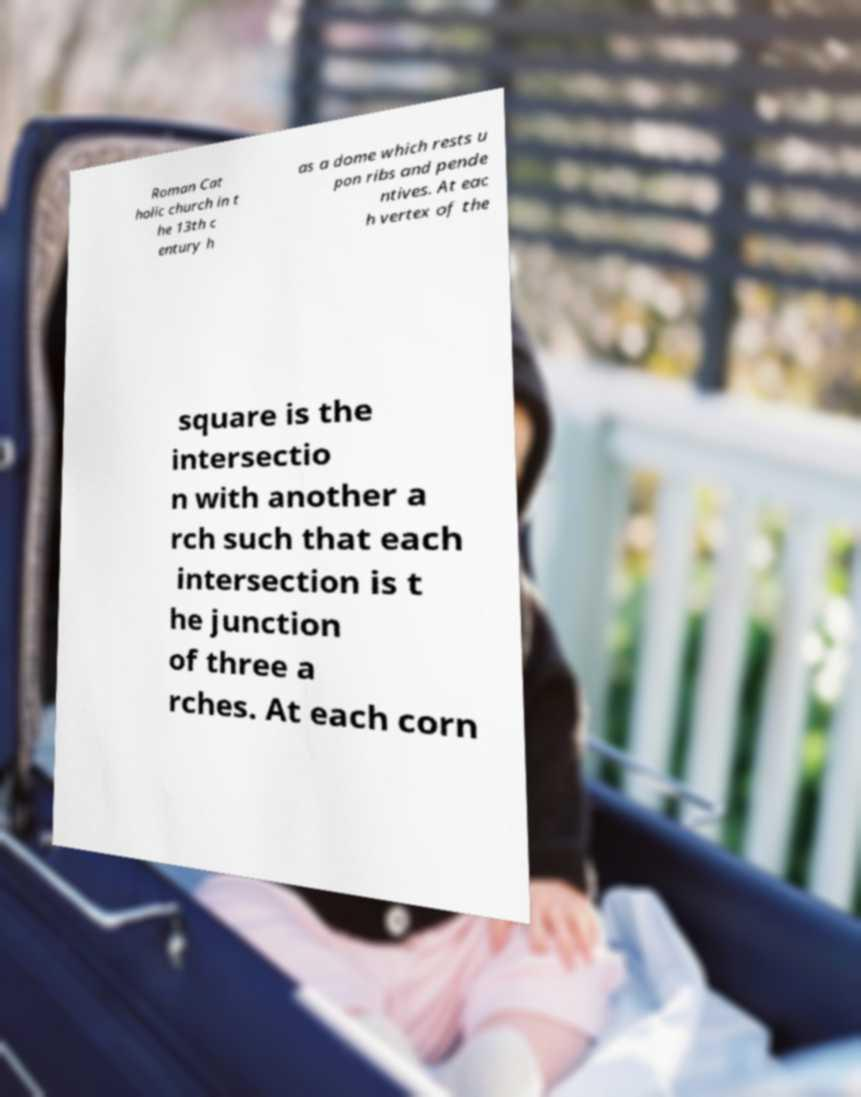Can you accurately transcribe the text from the provided image for me? Roman Cat holic church in t he 13th c entury h as a dome which rests u pon ribs and pende ntives. At eac h vertex of the square is the intersectio n with another a rch such that each intersection is t he junction of three a rches. At each corn 